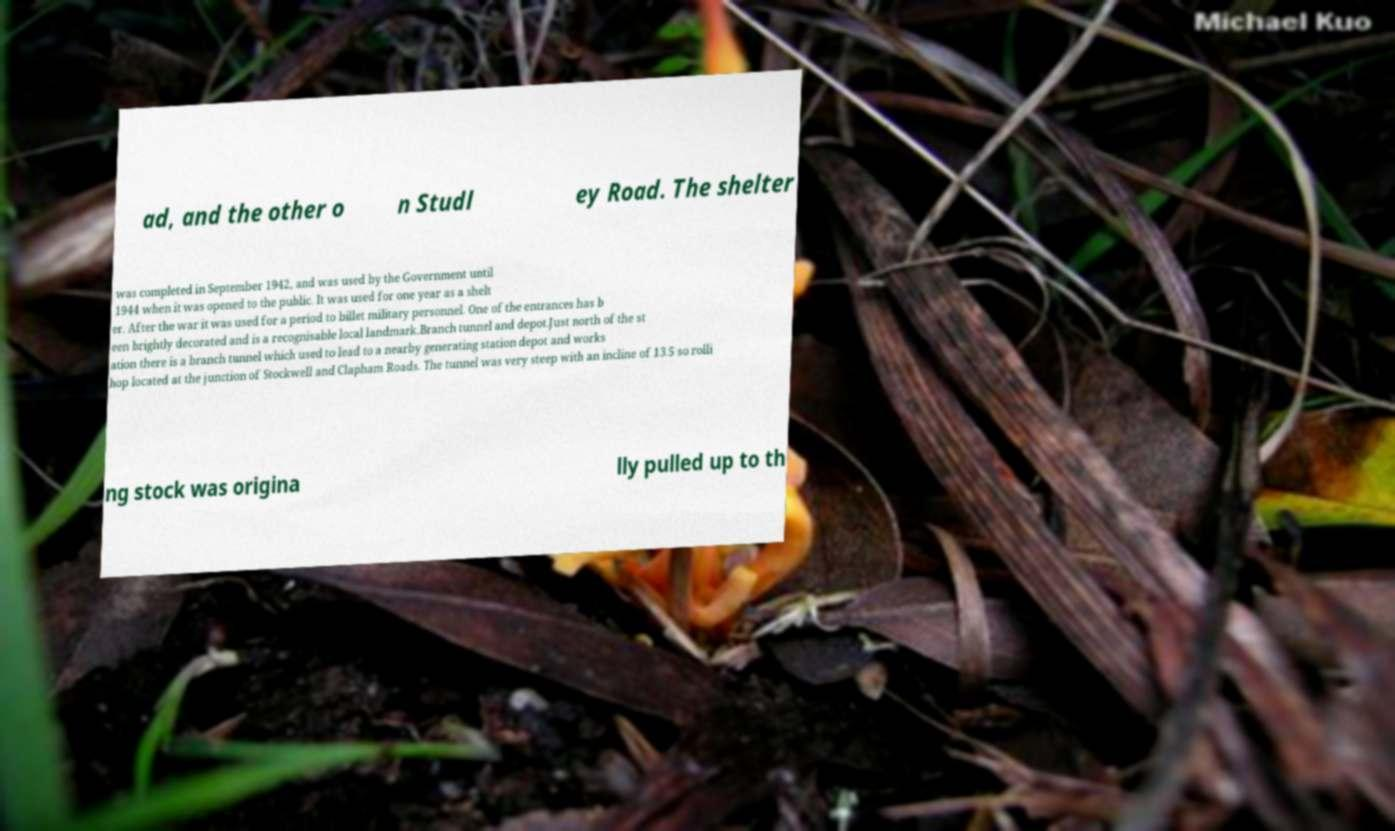Can you accurately transcribe the text from the provided image for me? ad, and the other o n Studl ey Road. The shelter was completed in September 1942, and was used by the Government until 1944 when it was opened to the public. It was used for one year as a shelt er. After the war it was used for a period to billet military personnel. One of the entrances has b een brightly decorated and is a recognisable local landmark.Branch tunnel and depot.Just north of the st ation there is a branch tunnel which used to lead to a nearby generating station depot and works hop located at the junction of Stockwell and Clapham Roads. The tunnel was very steep with an incline of 13.5 so rolli ng stock was origina lly pulled up to th 